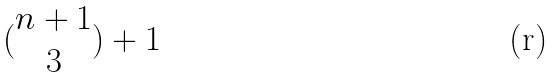Convert formula to latex. <formula><loc_0><loc_0><loc_500><loc_500>( \begin{matrix} n + 1 \\ 3 \end{matrix} ) + 1</formula> 